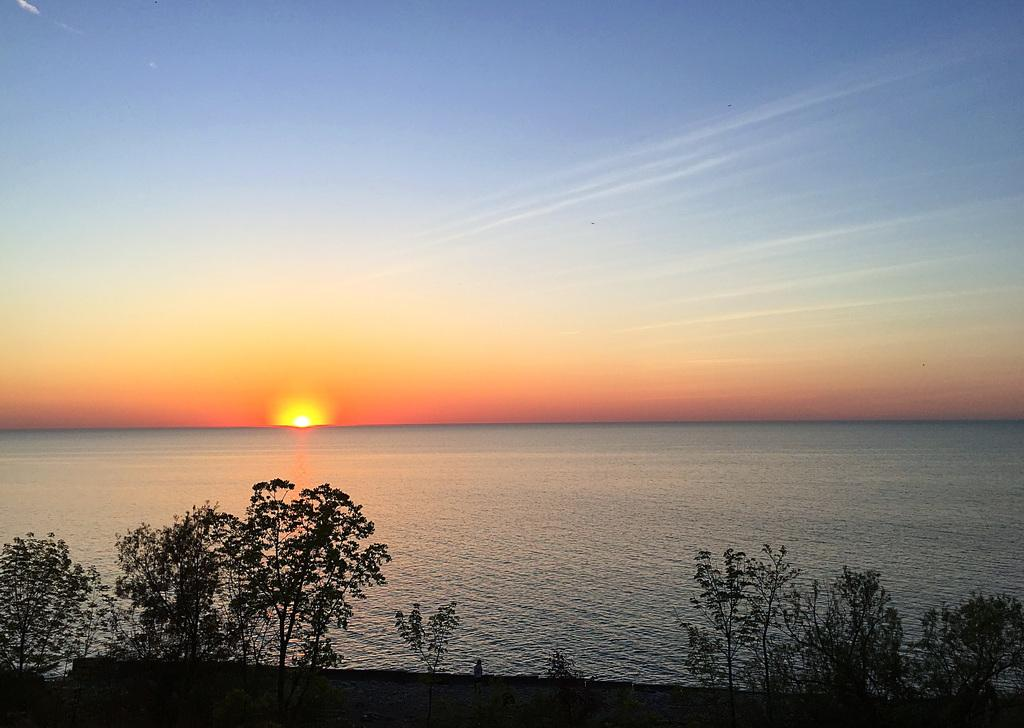What type of living organisms can be seen in the image? Plants can be seen in the image. What color are the plants? The plants are green. What can be seen in the background of the image? Water is visible in the background of the image. Can the sun be seen in the image? Yes, the sun is observable in the image. What colors are present in the sky? The sky has orange, yellow, blue, and white colors. What type of tin can be seen in the image? There is no tin present in the image. What is the smile of the tramp in the image? There is no tramp or smile in the image; it features plants, water, the sun, and a sky with various colors. 